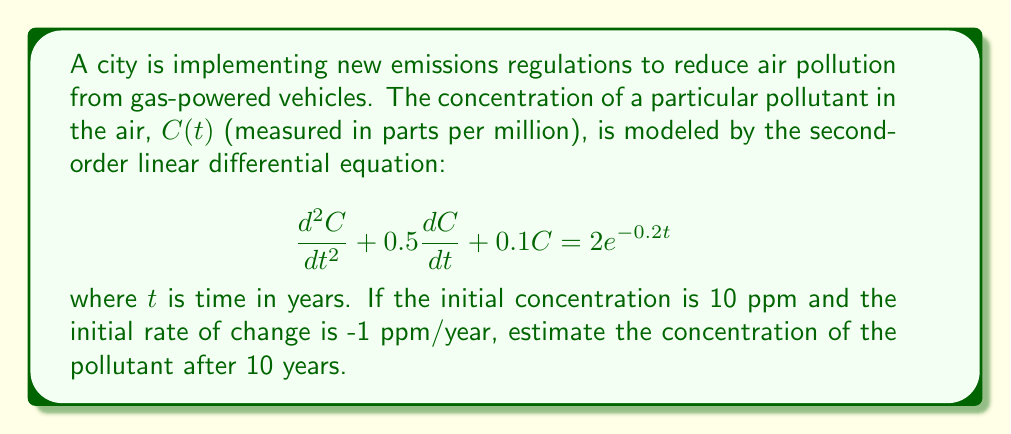Show me your answer to this math problem. To solve this problem, we need to follow these steps:

1) The general solution to this differential equation is the sum of the complementary function and the particular integral.

2) The complementary function has the form $C_c(t) = A_1e^{m_1t} + A_2e^{m_2t}$, where $m_1$ and $m_2$ are the roots of the characteristic equation:

   $$m^2 + 0.5m + 0.1 = 0$$

3) Solving this quadratic equation:
   
   $$m = \frac{-0.5 \pm \sqrt{0.5^2 - 4(1)(0.1)}}{2(1)} = \frac{-0.5 \pm \sqrt{0.05}}{2} \approx -0.3873 \text{ or } -0.1127$$

4) For the particular integral, we guess a solution of the form $C_p(t) = Be^{-0.2t}$. Substituting this into the original equation:

   $$(-0.2)^2Be^{-0.2t} + 0.5(-0.2)Be^{-0.2t} + 0.1Be^{-0.2t} = 2e^{-0.2t}$$
   
   $$(0.04 - 0.1 + 0.1)Be^{-0.2t} = 2e^{-0.2t}$$
   
   $$0.04B = 2$$
   
   $$B = 50$$

5) Therefore, the general solution is:

   $$C(t) = A_1e^{-0.3873t} + A_2e^{-0.1127t} + 50e^{-0.2t}$$

6) Using the initial conditions:

   At $t=0$, $C(0) = 10$, so:
   $$A_1 + A_2 + 50 = 10$$

   At $t=0$, $C'(0) = -1$, so:
   $$-0.3873A_1 - 0.1127A_2 - 10 = -1$$

7) Solving these simultaneous equations:

   $$A_1 \approx -24.7516$$
   $$A_2 \approx -15.2484$$

8) The final solution is:

   $$C(t) = -24.7516e^{-0.3873t} - 15.2484e^{-0.1127t} + 50e^{-0.2t}$$

9) To find the concentration after 10 years, we substitute $t=10$:

   $$C(10) = -24.7516e^{-3.873} - 15.2484e^{-1.127} + 50e^{-2}$$
Answer: $C(10) \approx 2.0396$ ppm 